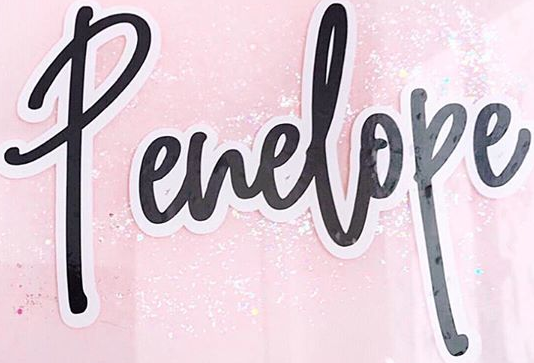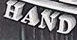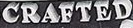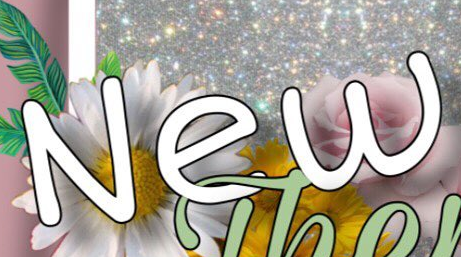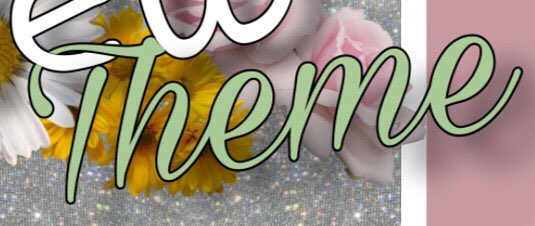Identify the words shown in these images in order, separated by a semicolon. Penelope; HAND; CRAFTED; New; Theme 